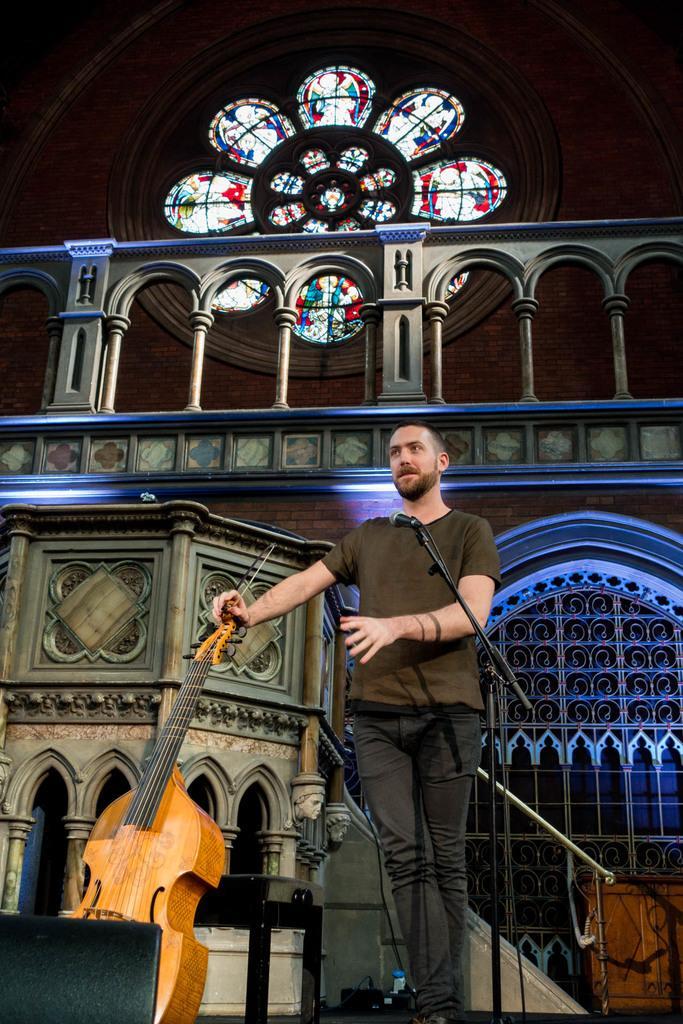Can you describe this image briefly? In this image the men is standing and holding a violin in-front there is mic,at the back ground there is a building. 